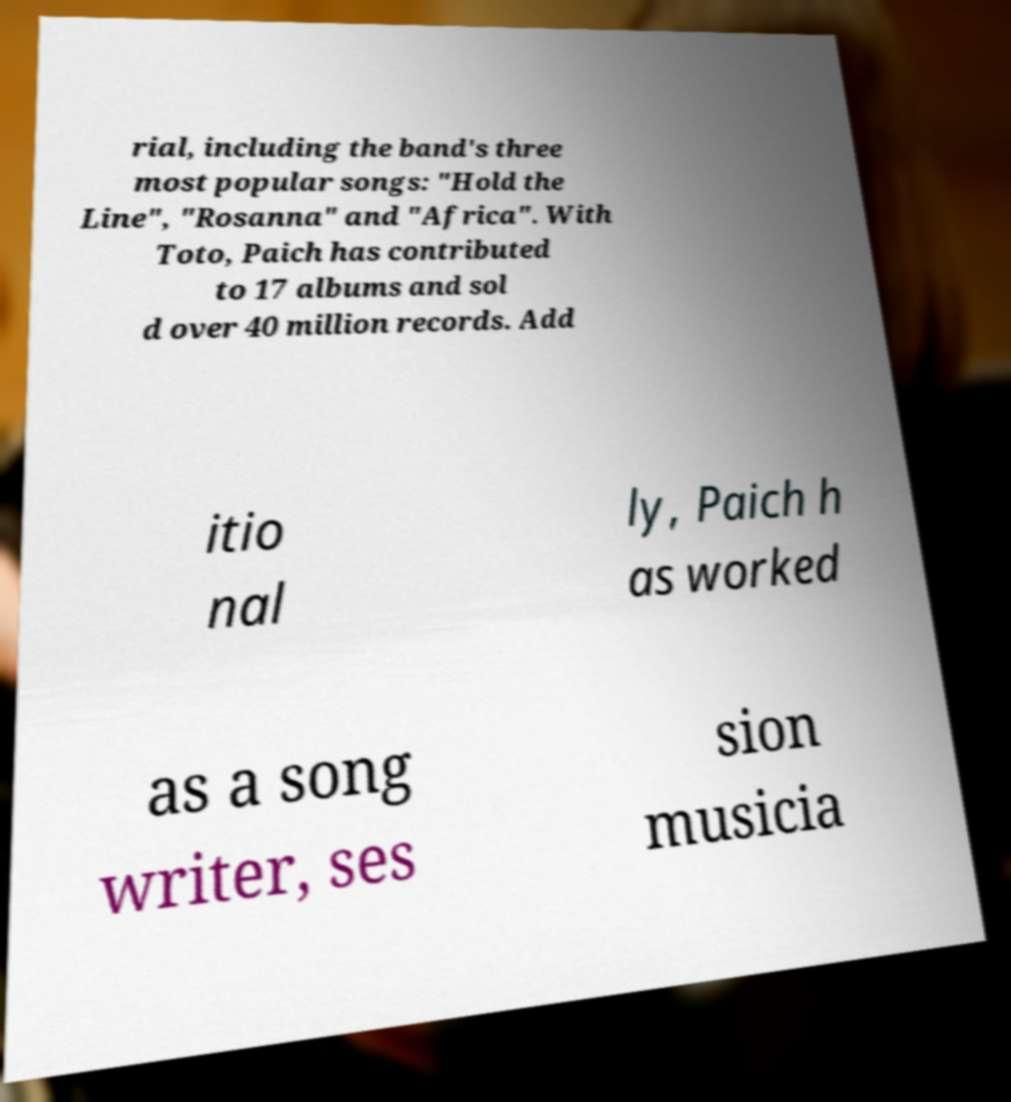I need the written content from this picture converted into text. Can you do that? rial, including the band's three most popular songs: "Hold the Line", "Rosanna" and "Africa". With Toto, Paich has contributed to 17 albums and sol d over 40 million records. Add itio nal ly, Paich h as worked as a song writer, ses sion musicia 